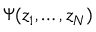<formula> <loc_0><loc_0><loc_500><loc_500>\Psi ( z _ { 1 } , \dots , z _ { N } )</formula> 